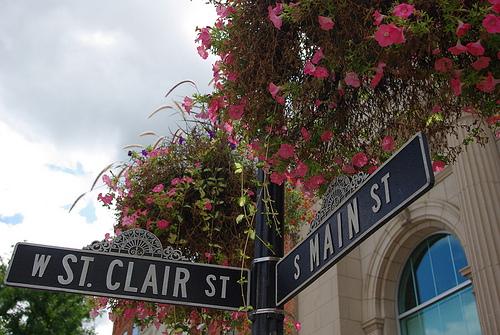How many people live in Main Street?
Concise answer only. 100. What directions does Main Street run?
Quick response, please. South. What is the weather like?
Give a very brief answer. Cloudy. What color are the flowers?
Write a very short answer. Pink. 